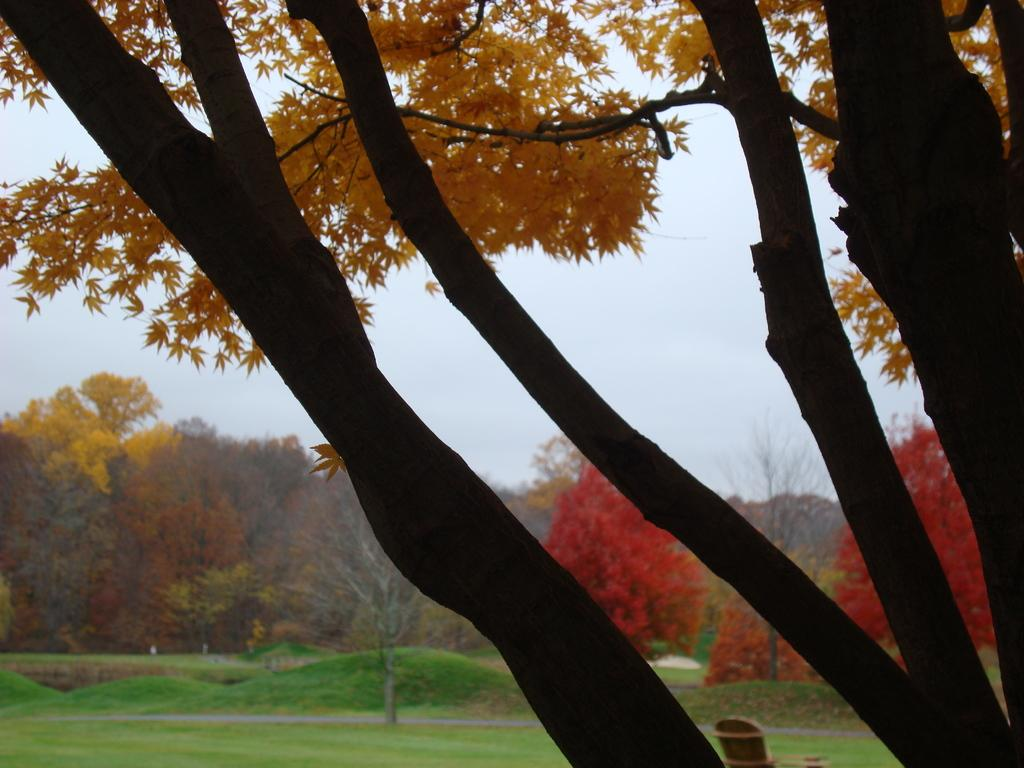What type of vegetation is present in the image? There are trees in the image. What else can be seen on the ground in the image? There is grass in the image. What is visible in the background of the image? The sky is visible in the background of the image. How many fish can be seen swimming in the grass in the image? There are no fish present in the image; it features trees, grass, and the sky. What type of acoustics can be heard in the image? The image is a still picture, so there are no sounds or acoustics present. 